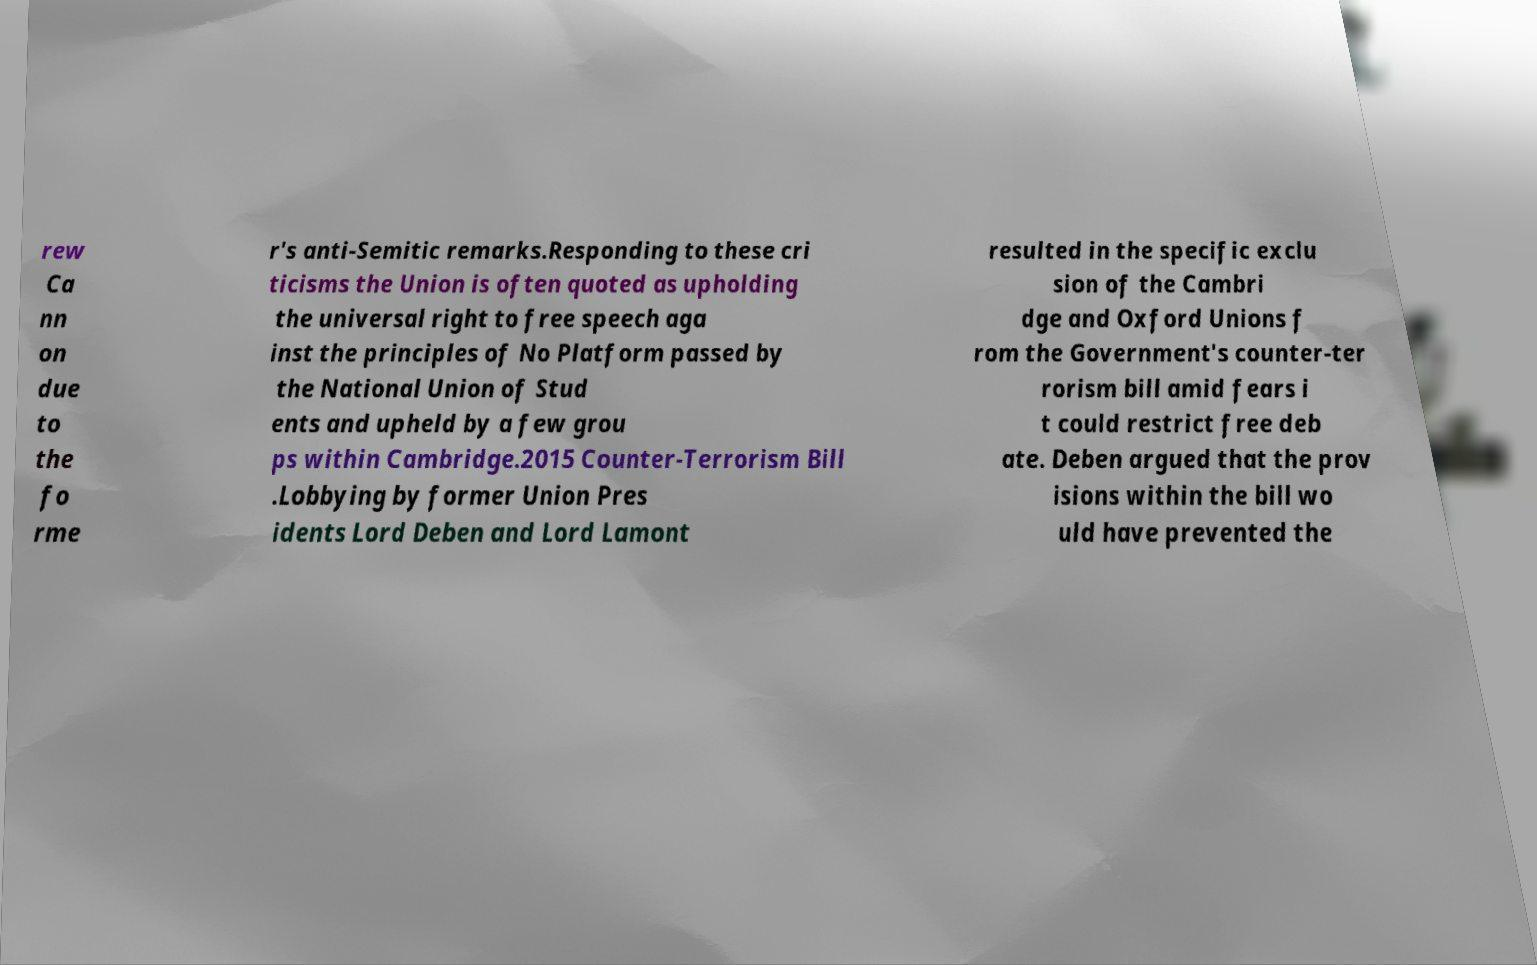Please read and relay the text visible in this image. What does it say? rew Ca nn on due to the fo rme r's anti-Semitic remarks.Responding to these cri ticisms the Union is often quoted as upholding the universal right to free speech aga inst the principles of No Platform passed by the National Union of Stud ents and upheld by a few grou ps within Cambridge.2015 Counter-Terrorism Bill .Lobbying by former Union Pres idents Lord Deben and Lord Lamont resulted in the specific exclu sion of the Cambri dge and Oxford Unions f rom the Government's counter-ter rorism bill amid fears i t could restrict free deb ate. Deben argued that the prov isions within the bill wo uld have prevented the 